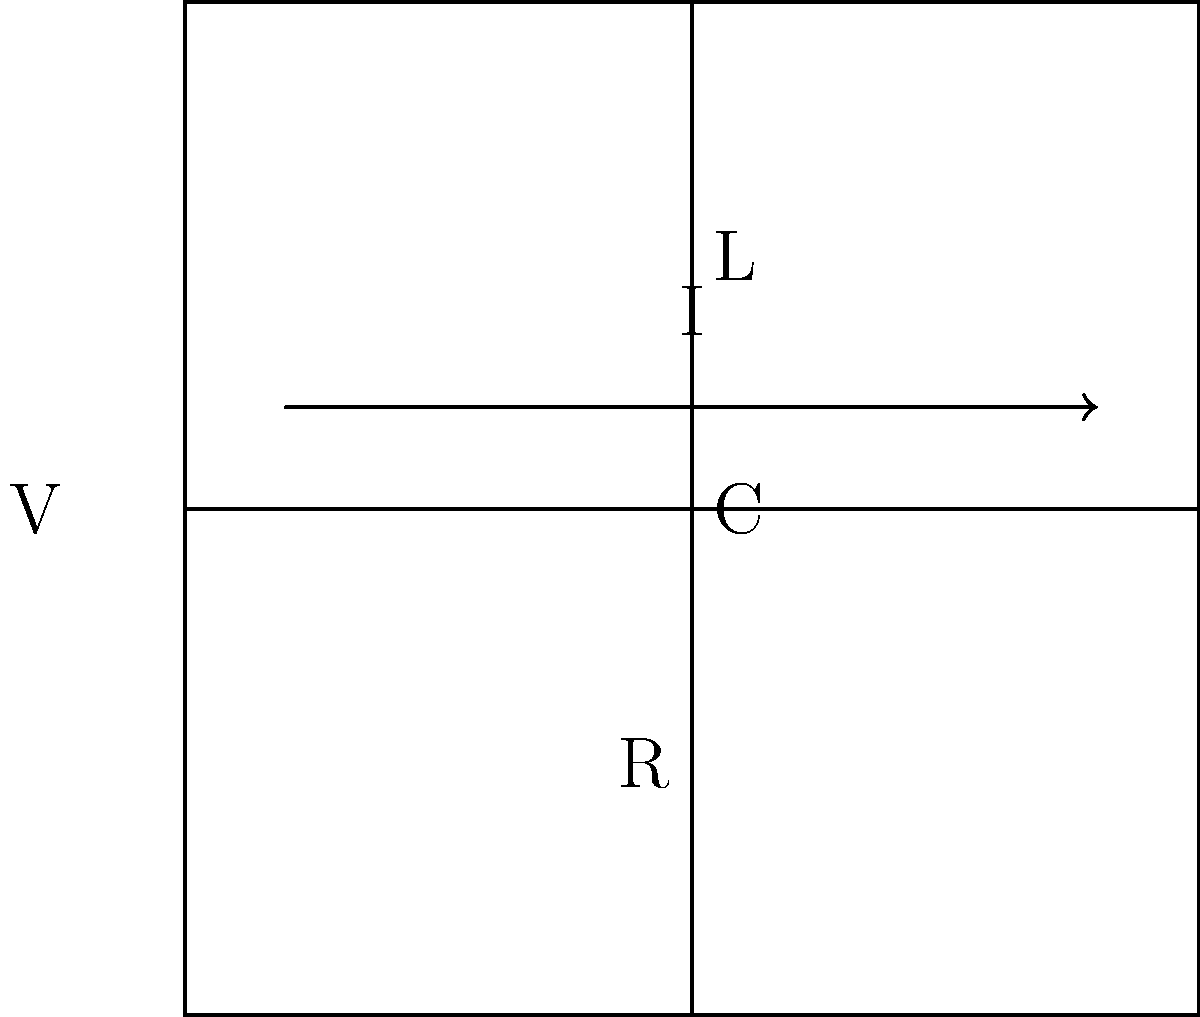In a security screening device, an RLC circuit is used for metal detection. The circuit consists of a resistor (R), an inductor (L), and a capacitor (C) in series with a voltage source (V). If the resonant frequency of this circuit is 1 MHz and the inductance is 100 μH, what is the capacitance of the circuit? To solve this problem, we'll use the resonant frequency formula for an RLC circuit and follow these steps:

1. Recall the formula for resonant frequency in an RLC circuit:
   $$ f = \frac{1}{2\pi\sqrt{LC}} $$
   where $f$ is the resonant frequency, $L$ is the inductance, and $C$ is the capacitance.

2. We're given:
   $f = 1 \text{ MHz} = 1 \times 10^6 \text{ Hz}$
   $L = 100 \text{ μH} = 100 \times 10^{-6} \text{ H}$

3. Substitute these values into the formula:
   $$ 1 \times 10^6 = \frac{1}{2\pi\sqrt{(100 \times 10^{-6})C}} $$

4. Square both sides:
   $$ (1 \times 10^6)^2 = \frac{1}{4\pi^2(100 \times 10^{-6})C} $$

5. Simplify:
   $$ 1 \times 10^{12} = \frac{1}{4\pi^2(100 \times 10^{-6})C} $$

6. Multiply both sides by $4\pi^2(100 \times 10^{-6})C$:
   $$ 4\pi^2(100 \times 10^{-6})C \times 1 \times 10^{12} = 1 $$

7. Solve for C:
   $$ C = \frac{1}{4\pi^2(100 \times 10^{-6}) \times 1 \times 10^{12}} $$

8. Calculate the result:
   $$ C \approx 253.3 \text{ pF} $$

Therefore, the capacitance of the circuit is approximately 253.3 pF.
Answer: 253.3 pF 